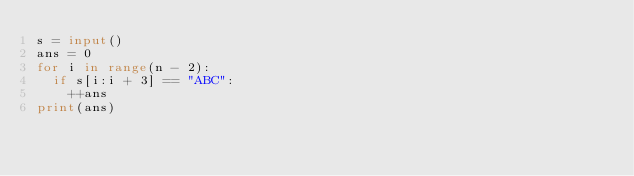Convert code to text. <code><loc_0><loc_0><loc_500><loc_500><_Python_>s = input()
ans = 0
for i in range(n - 2):
  if s[i:i + 3] == "ABC":
    ++ans
print(ans)</code> 